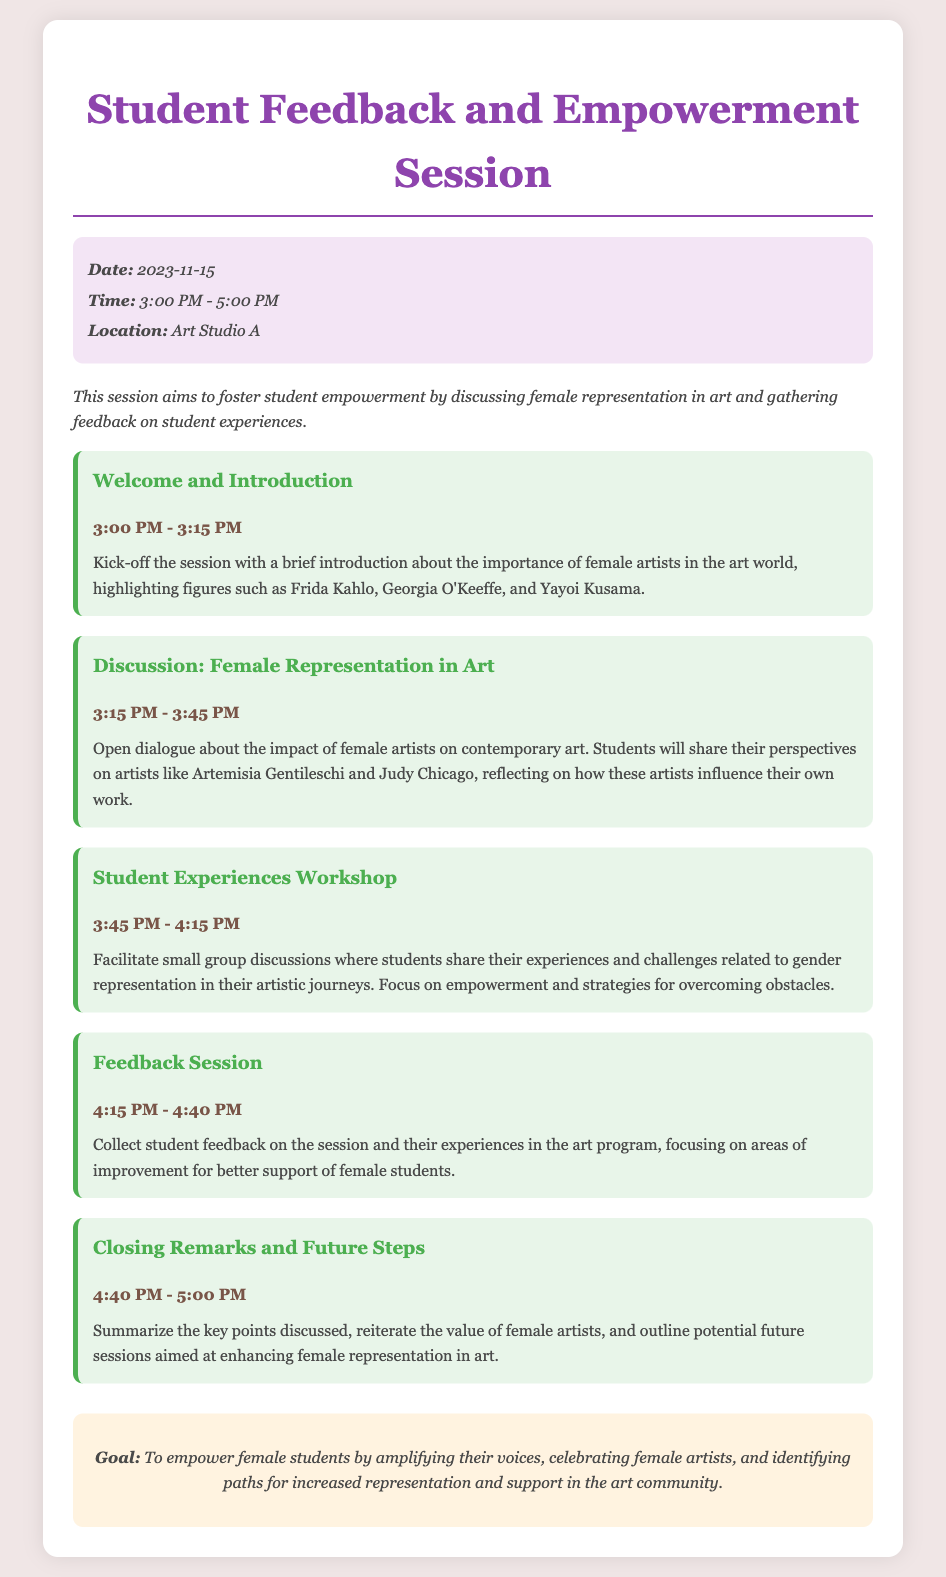What is the date of the session? The date of the session is mentioned in the session info section of the document.
Answer: 2023-11-15 What time does the session start? The start time of the session is listed in the session info section.
Answer: 3:00 PM Who are some female artists highlighted in the introduction? The introduction specifies several female artists that are significant in the art world.
Answer: Frida Kahlo, Georgia O'Keeffe, Yayoi Kusama What is the focus of the Student Experiences Workshop? The focus of this part of the agenda is outlined in the description provided for the workshop.
Answer: Experiences and challenges related to gender representation What is the goal of this session? The goal is summarized in the final section of the agenda.
Answer: To empower female students by amplifying their voices How long is the Feedback Session? The duration of the Feedback Session can be calculated from the time slots given in the agenda.
Answer: 25 minutes What is the closing time of the session? The closing time is specified in the agenda, giving information about when the session will end.
Answer: 5:00 PM Which female artist mentioned is known for her work in the 17th century? The document references an artist recognized for her contributions during a specific historical period.
Answer: Artemisia Gentileschi 